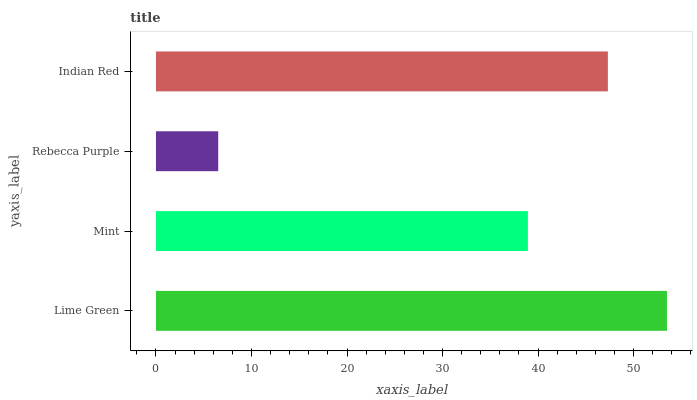Is Rebecca Purple the minimum?
Answer yes or no. Yes. Is Lime Green the maximum?
Answer yes or no. Yes. Is Mint the minimum?
Answer yes or no. No. Is Mint the maximum?
Answer yes or no. No. Is Lime Green greater than Mint?
Answer yes or no. Yes. Is Mint less than Lime Green?
Answer yes or no. Yes. Is Mint greater than Lime Green?
Answer yes or no. No. Is Lime Green less than Mint?
Answer yes or no. No. Is Indian Red the high median?
Answer yes or no. Yes. Is Mint the low median?
Answer yes or no. Yes. Is Rebecca Purple the high median?
Answer yes or no. No. Is Rebecca Purple the low median?
Answer yes or no. No. 